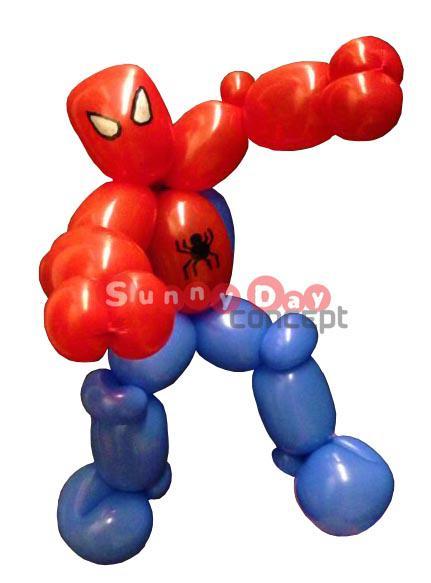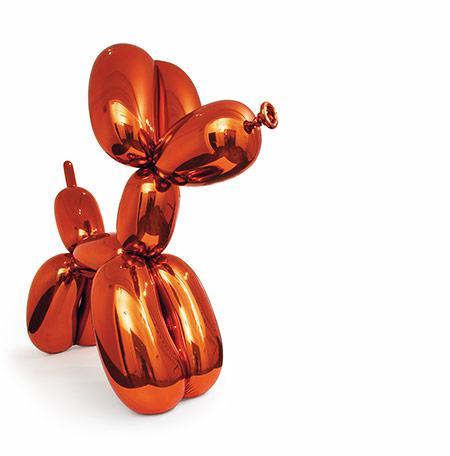The first image is the image on the left, the second image is the image on the right. Evaluate the accuracy of this statement regarding the images: "The right-hand image features a single balloon animal.". Is it true? Answer yes or no. Yes. 